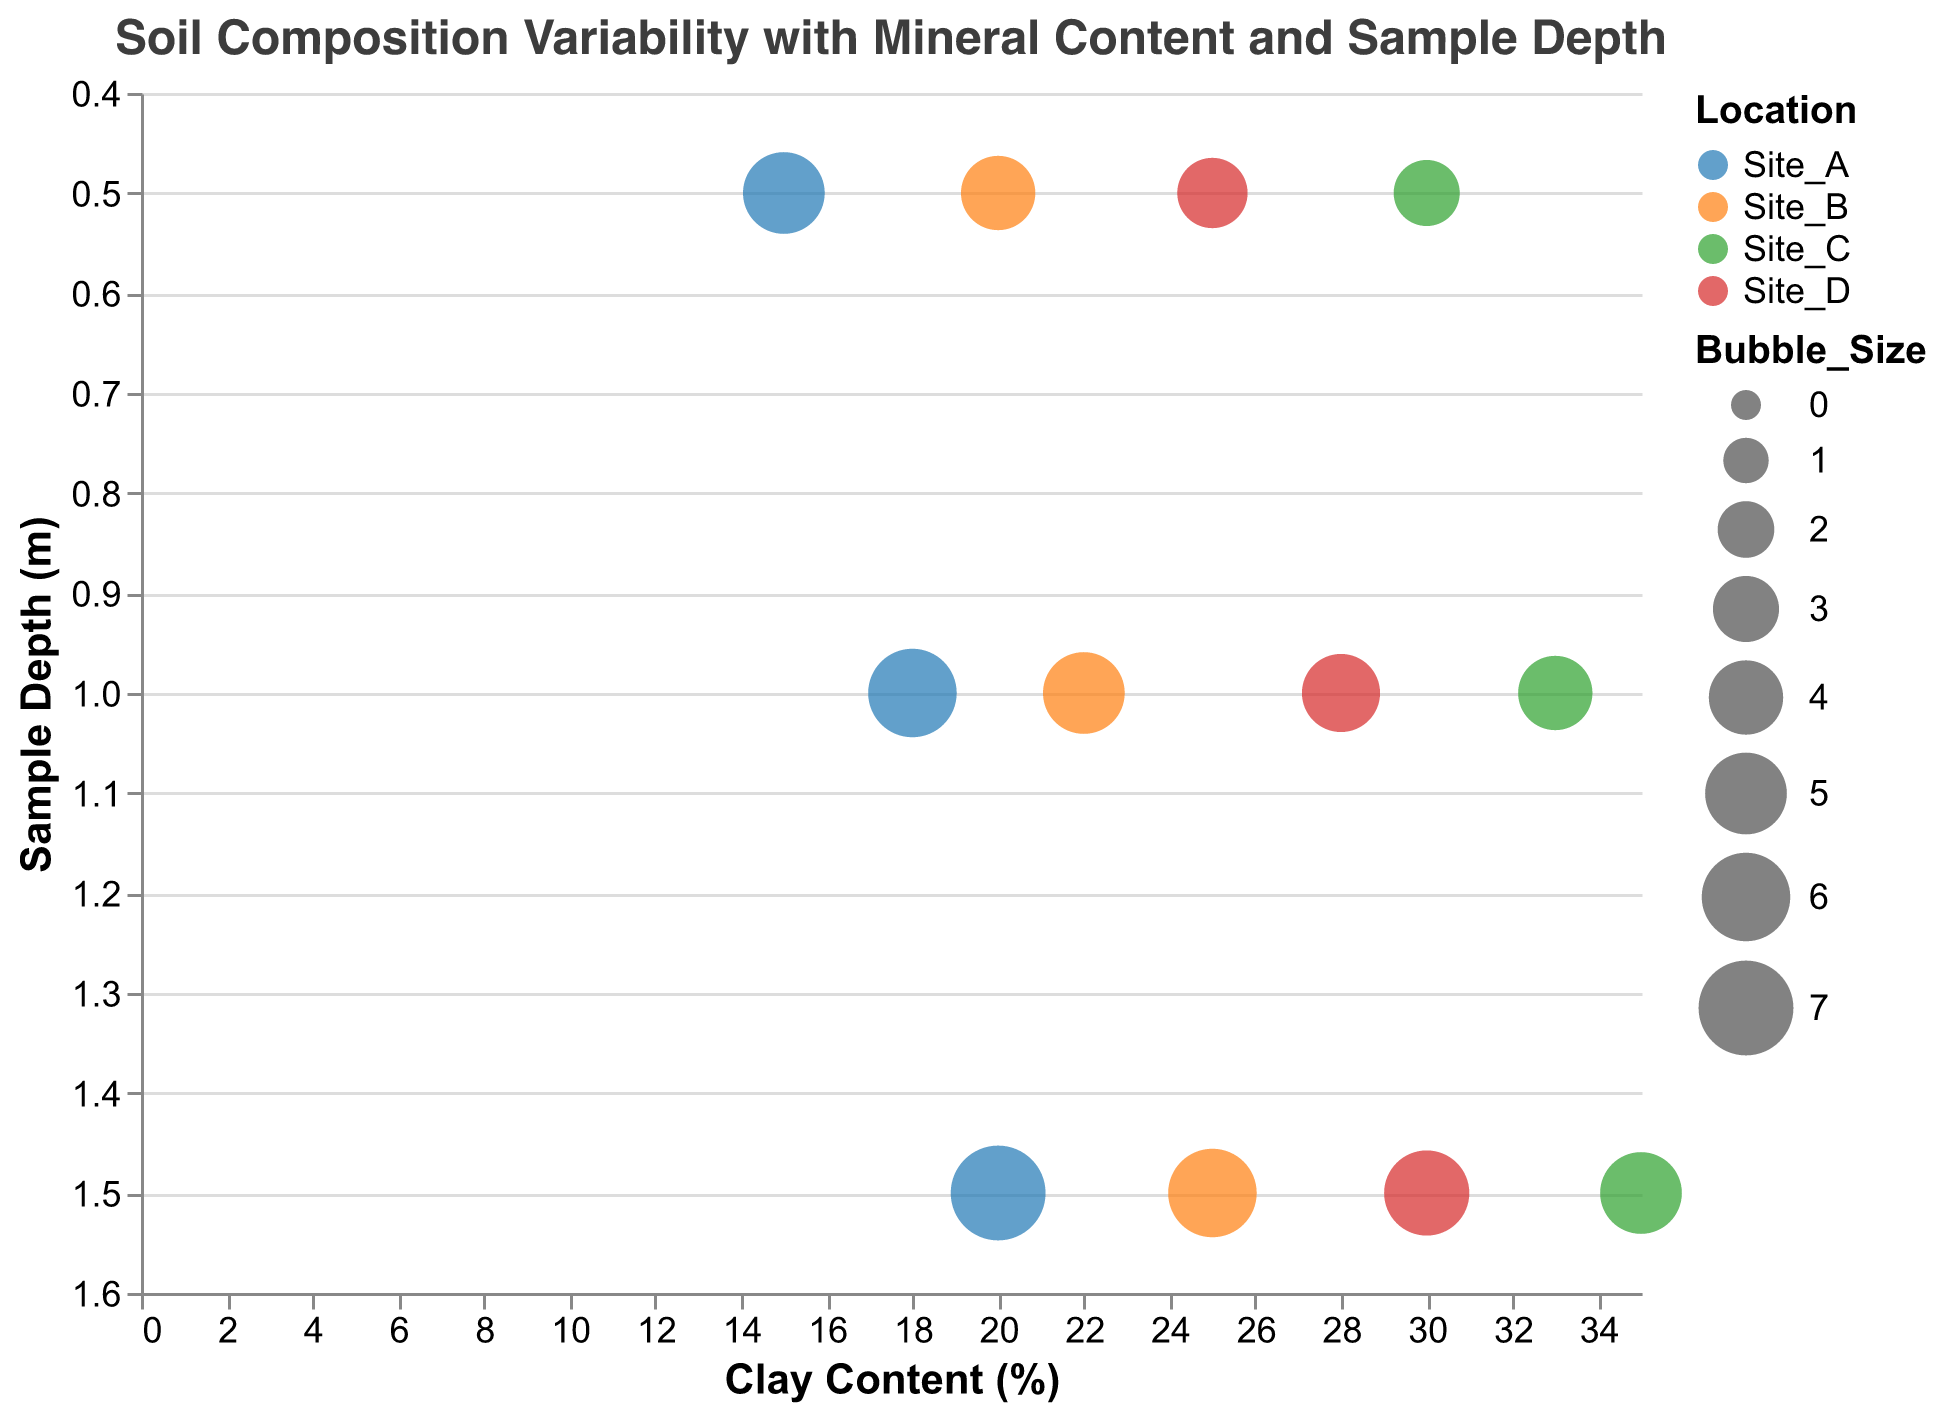What is the title of the bubble chart? The title of the chart is displayed at the top, reading "Soil Composition Variability with Mineral Content and Sample Depth."
Answer: Soil Composition Variability with Mineral Content and Sample Depth How many unique locations are represented in the dataset? Each bubble is colored differently based on the location. By referencing the color legend on the figure, we can count the unique locations: Site_A, Site_B, Site_C, and Site_D.
Answer: 4 What variable is represented by the x-axis? The x-axis is labeled "Clay Content (%)" which indicates that the horizontal position of each bubble is determined by its clay content percentage.
Answer: Clay Content (%) What is the depth of the sample with the highest mineral content? The tooltip information provides details for each bubble. The sample with the highest mineral content (1500 mg/kg) is at a depth of 1.5 meters at Site_A.
Answer: 1.5 meters Which site has the smallest bubble at 1.0 meters depth and what could this imply? By examining the bubble sizes at the depth of 1.0 meters, Site_C has the smallest bubble, which is associated with the lowest clay content and correspondingly lower mineral content, suggesting less variability.
Answer: Site_C Compare the clay content of samples at 0.5 meters depth between Site_A and Site_B. Site_A has 15% clay at 0.5 meters while Site_B has 20% clay at the same depth, as indicated by the x-axis positions of the respective bubbles.
Answer: Site_A: 15%, Site_B: 20% What is the trend in clay content with increasing depth for Site_D? By tracking the bubble positions along the x-axis for Site_D at different depths (0.5m: 25%, 1.0m: 28%, 1.5m: 30%), we observe an increasing clay content with depth.
Answer: Increasing Which sample shows the largest bubble size, and what is its depth? The largest bubble represents a bubble size of 7 for Site_A at a depth of 1.5 meters. This suggests a combination of high clay content and high variability in mineral content.
Answer: Site_A at 1.5 meters What is the average mineral content for samples at Site_C? Mineral content values for Site_C are 1000, 1150, and 1300 mg/kg. The average is calculated as (1000 + 1150 + 1300) / 3 = 1150 mg/kg.
Answer: 1150 mg/kg How does the mineral content at Site_B vary with depth? Examining Site_B, the mineral content values are 1100 mg/kg (0.5m), 1250 mg/kg (1.0m), and 1400 mg/kg (1.5m). There is a clear increasing trend with depth.
Answer: Increasing 